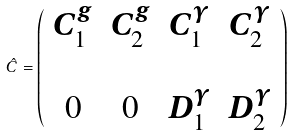Convert formula to latex. <formula><loc_0><loc_0><loc_500><loc_500>\hat { C } = \left ( \begin{array} { c c c c } C _ { 1 } ^ { g } & C _ { 2 } ^ { g } & C _ { 1 } ^ { \gamma } & C _ { 2 } ^ { \gamma } \\ & & & \\ 0 & 0 & D _ { 1 } ^ { \gamma } & D _ { 2 } ^ { \gamma } \\ \end{array} \right )</formula> 